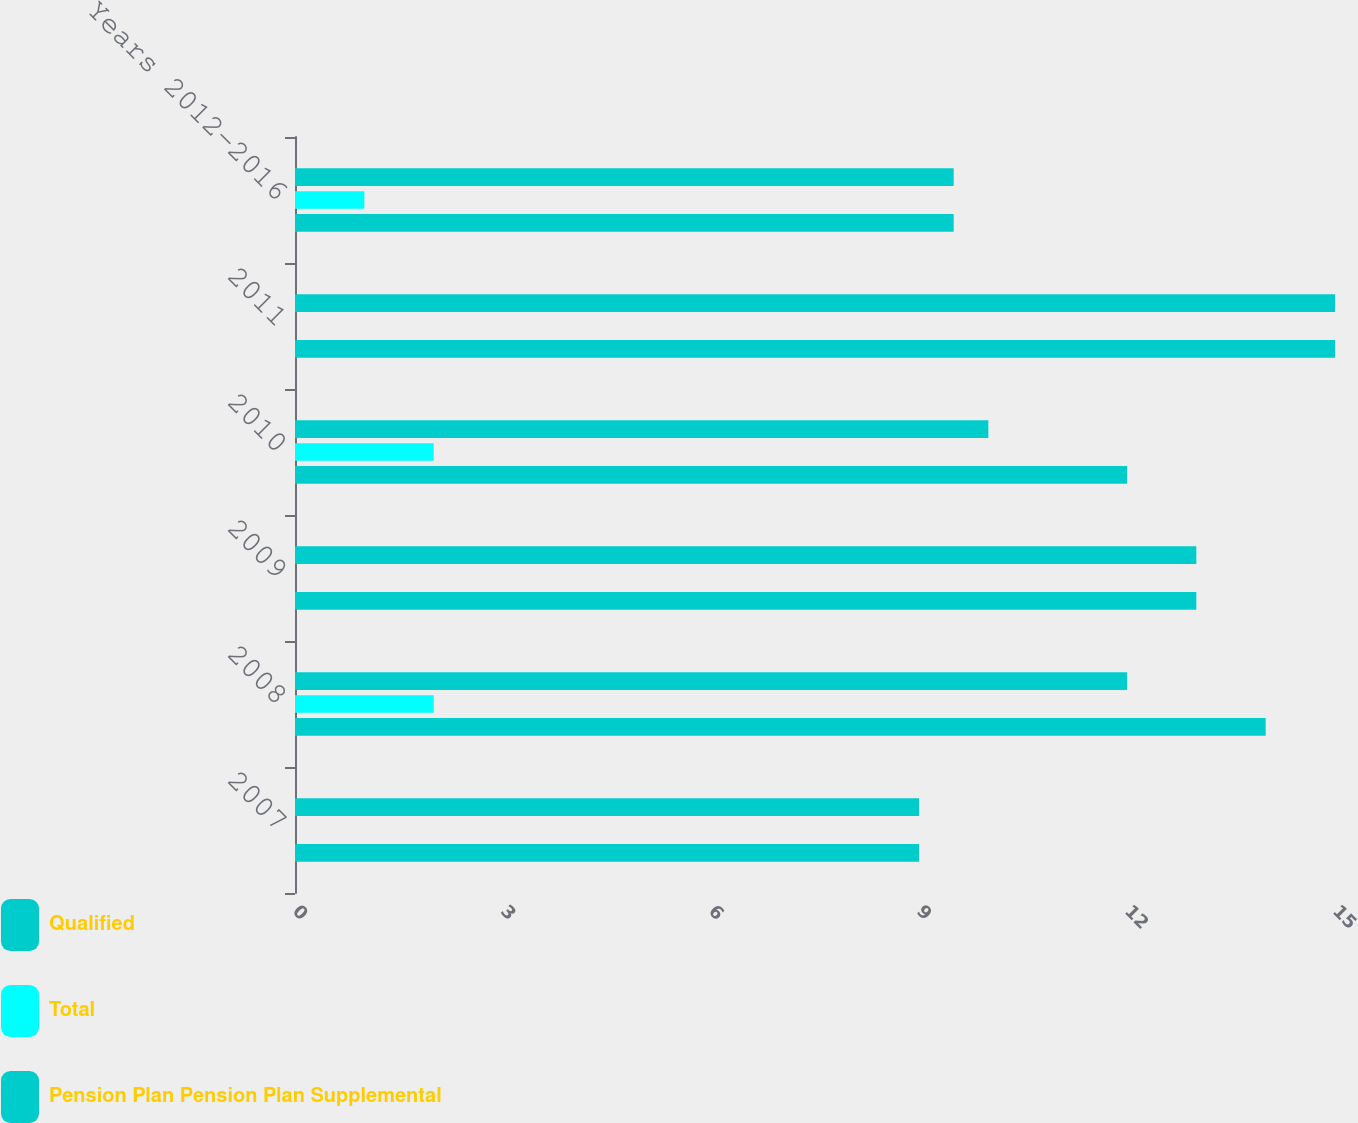Convert chart. <chart><loc_0><loc_0><loc_500><loc_500><stacked_bar_chart><ecel><fcel>2007<fcel>2008<fcel>2009<fcel>2010<fcel>2011<fcel>Years 2012-2016<nl><fcel>Qualified<fcel>9<fcel>12<fcel>13<fcel>10<fcel>15<fcel>9.5<nl><fcel>Total<fcel>0<fcel>2<fcel>0<fcel>2<fcel>0<fcel>1<nl><fcel>Pension Plan Pension Plan Supplemental<fcel>9<fcel>14<fcel>13<fcel>12<fcel>15<fcel>9.5<nl></chart> 